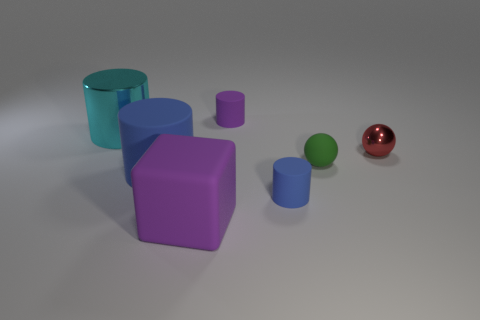Add 3 tiny rubber cylinders. How many objects exist? 10 Subtract all spheres. How many objects are left? 5 Subtract 0 cyan blocks. How many objects are left? 7 Subtract all large rubber things. Subtract all blue cylinders. How many objects are left? 3 Add 1 big cyan objects. How many big cyan objects are left? 2 Add 4 large red metal objects. How many large red metal objects exist? 4 